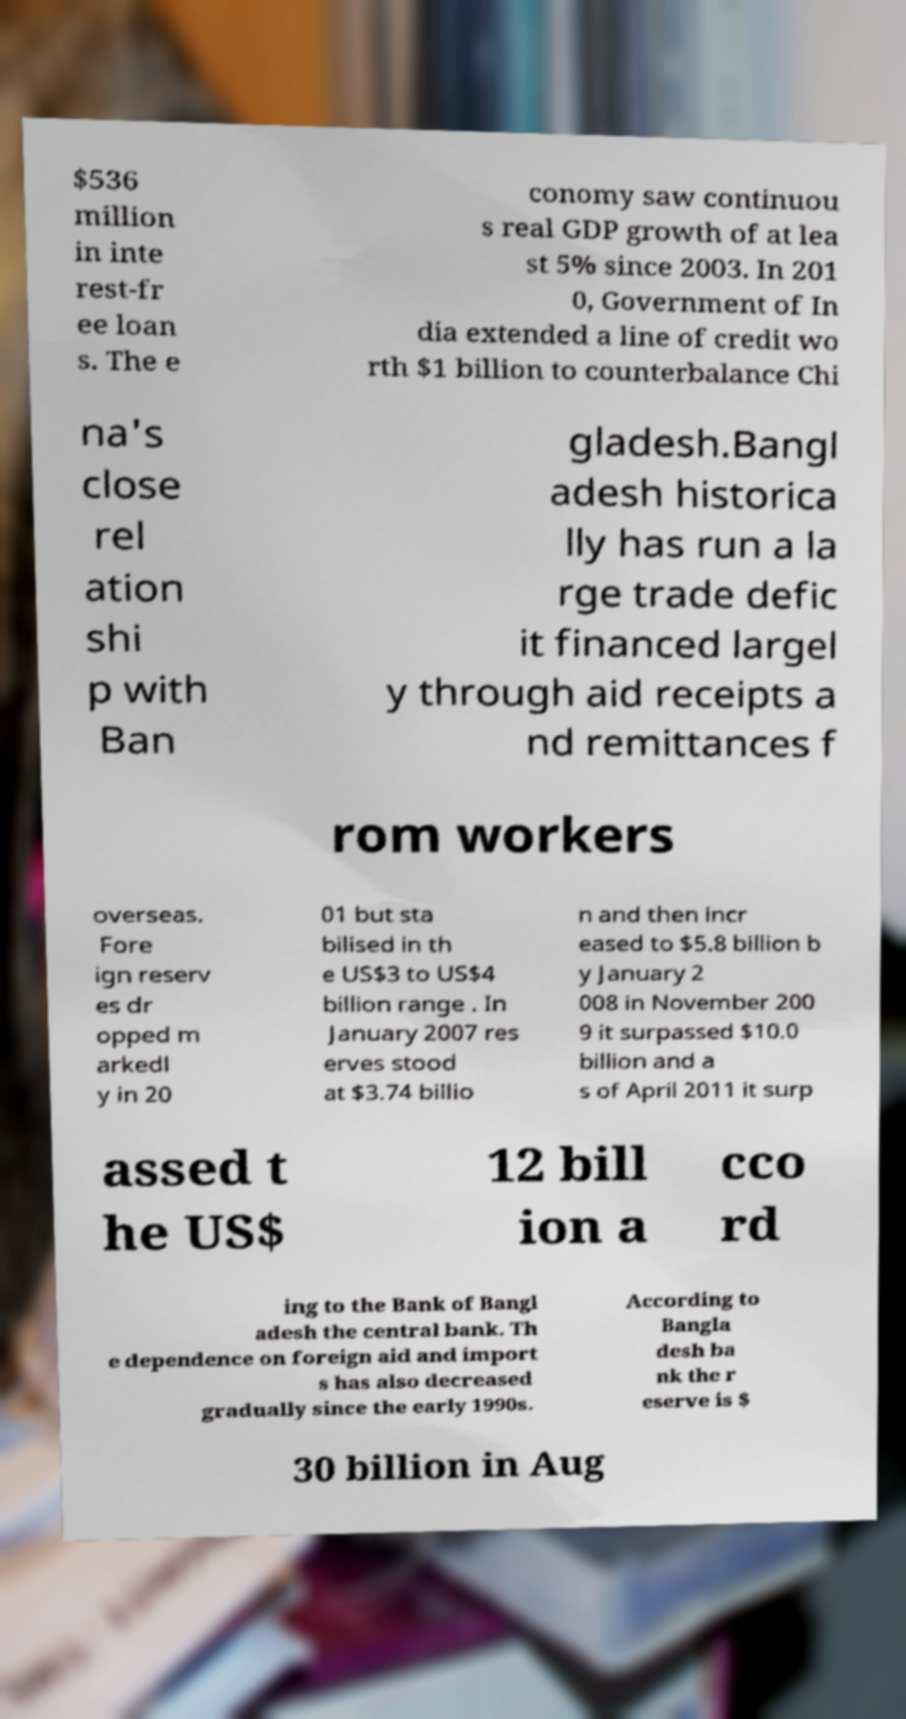There's text embedded in this image that I need extracted. Can you transcribe it verbatim? $536 million in inte rest-fr ee loan s. The e conomy saw continuou s real GDP growth of at lea st 5% since 2003. In 201 0, Government of In dia extended a line of credit wo rth $1 billion to counterbalance Chi na's close rel ation shi p with Ban gladesh.Bangl adesh historica lly has run a la rge trade defic it financed largel y through aid receipts a nd remittances f rom workers overseas. Fore ign reserv es dr opped m arkedl y in 20 01 but sta bilised in th e US$3 to US$4 billion range . In January 2007 res erves stood at $3.74 billio n and then incr eased to $5.8 billion b y January 2 008 in November 200 9 it surpassed $10.0 billion and a s of April 2011 it surp assed t he US$ 12 bill ion a cco rd ing to the Bank of Bangl adesh the central bank. Th e dependence on foreign aid and import s has also decreased gradually since the early 1990s. According to Bangla desh ba nk the r eserve is $ 30 billion in Aug 